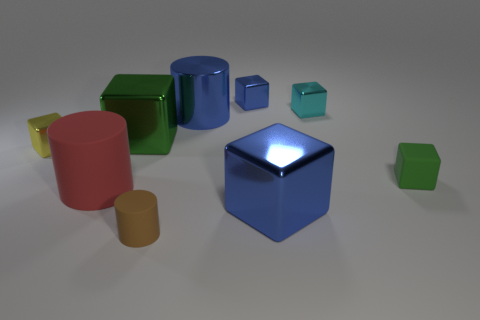Subtract 4 cubes. How many cubes are left? 2 Subtract all cyan blocks. How many blocks are left? 5 Subtract all blue blocks. How many blocks are left? 4 Subtract all cyan cubes. Subtract all yellow spheres. How many cubes are left? 5 Add 1 tiny blue metal blocks. How many objects exist? 10 Subtract 1 brown cylinders. How many objects are left? 8 Subtract all cylinders. How many objects are left? 6 Subtract all brown cylinders. Subtract all tiny brown matte things. How many objects are left? 7 Add 1 green rubber objects. How many green rubber objects are left? 2 Add 9 big red things. How many big red things exist? 10 